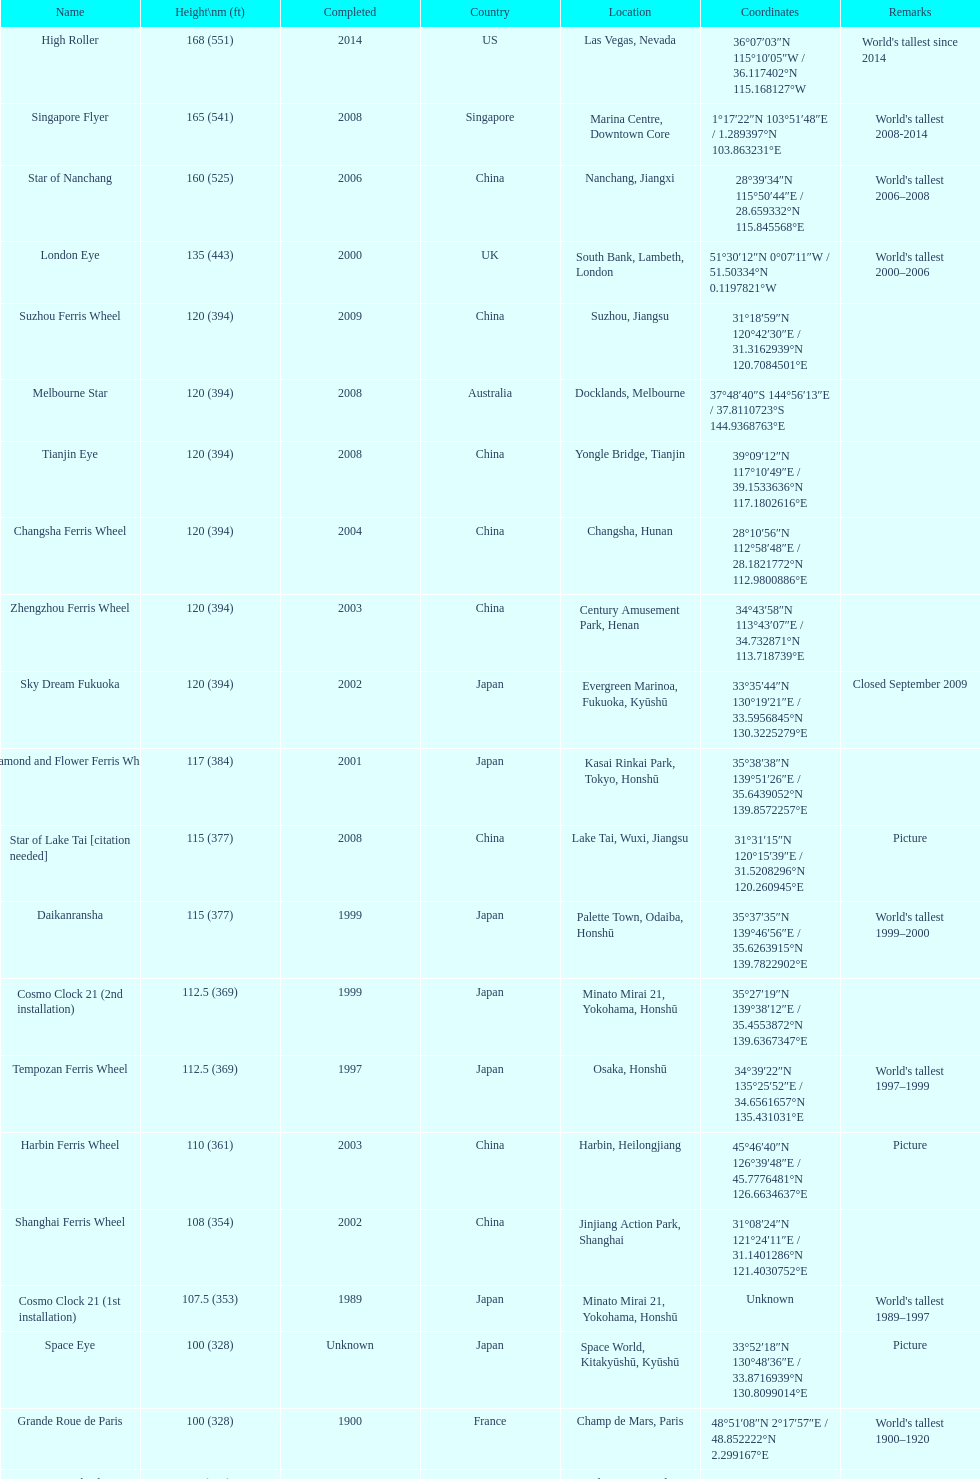Which ferris wheel was completed in 2008 and has the height of 165? Singapore Flyer. 